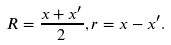<formula> <loc_0><loc_0><loc_500><loc_500>R = \frac { x + x ^ { \prime } } { 2 } , r = x - x ^ { \prime } .</formula> 